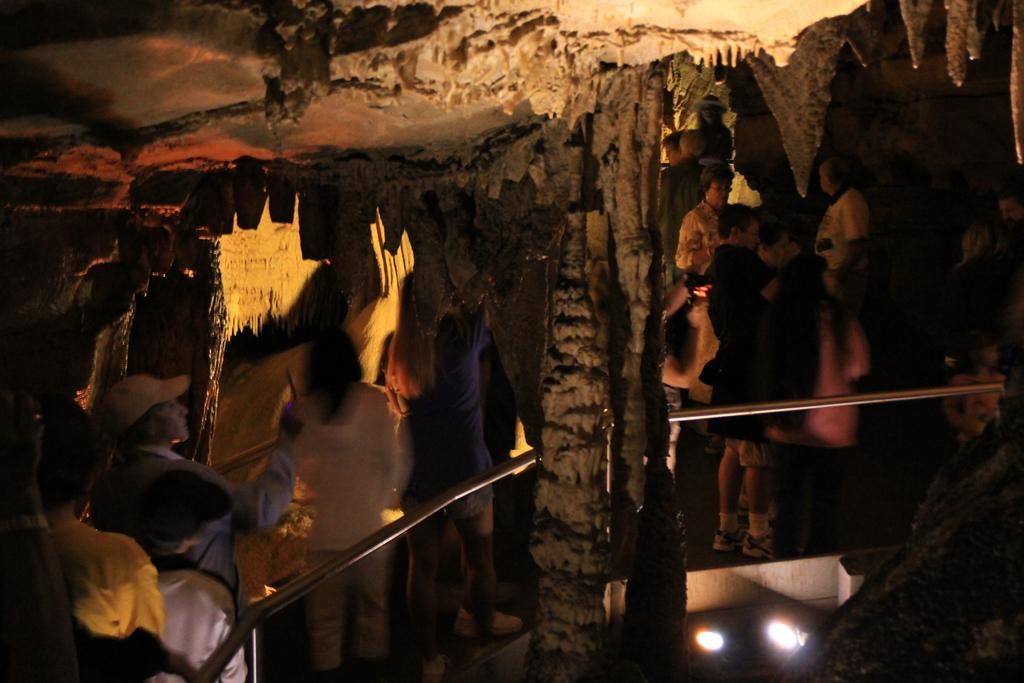What can be seen in the image? There are people standing in the image. What else is visible in the image besides the people? There are lights visible in the image. Can you describe the setting of the image? The image appears to depict a cave. What type of cabbage is being harvested in the image? There is no cabbage present in the image; it depicts people standing in a cave with visible lights. How does the dock contribute to the scene in the image? There is no dock present in the image; it depicts people standing in a cave with visible lights. 